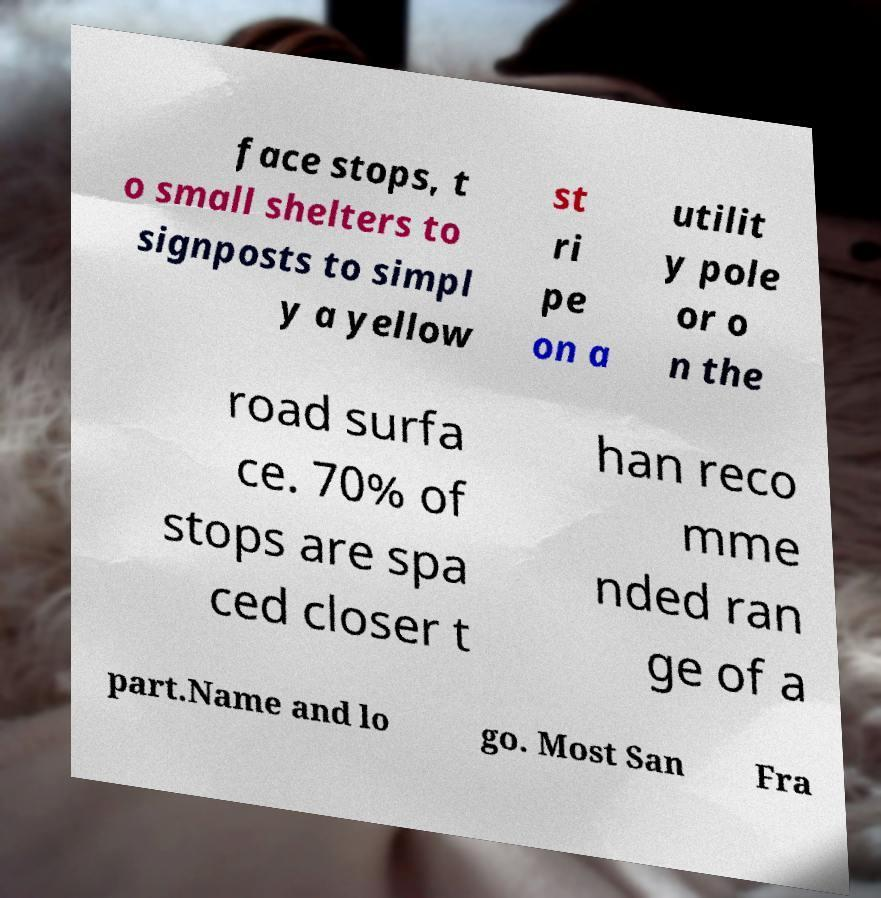Could you extract and type out the text from this image? face stops, t o small shelters to signposts to simpl y a yellow st ri pe on a utilit y pole or o n the road surfa ce. 70% of stops are spa ced closer t han reco mme nded ran ge of a part.Name and lo go. Most San Fra 